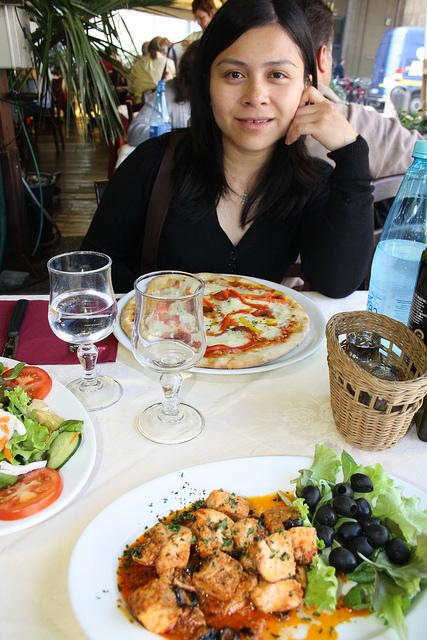What is the woman in black about to eat? pizza 